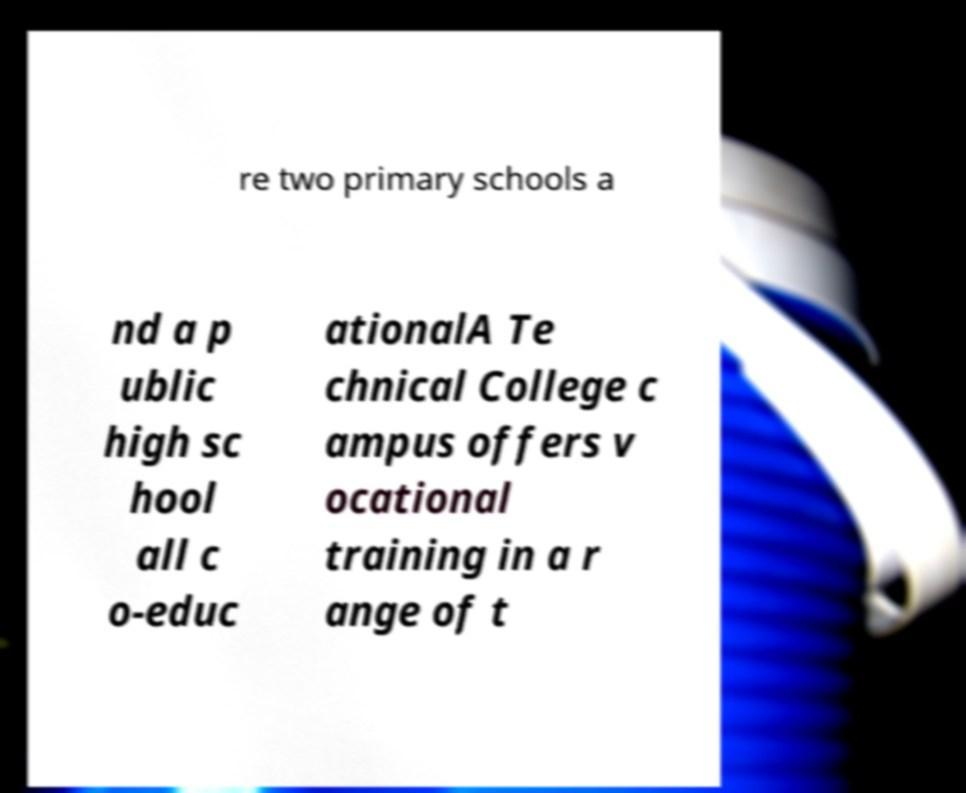There's text embedded in this image that I need extracted. Can you transcribe it verbatim? re two primary schools a nd a p ublic high sc hool all c o-educ ationalA Te chnical College c ampus offers v ocational training in a r ange of t 